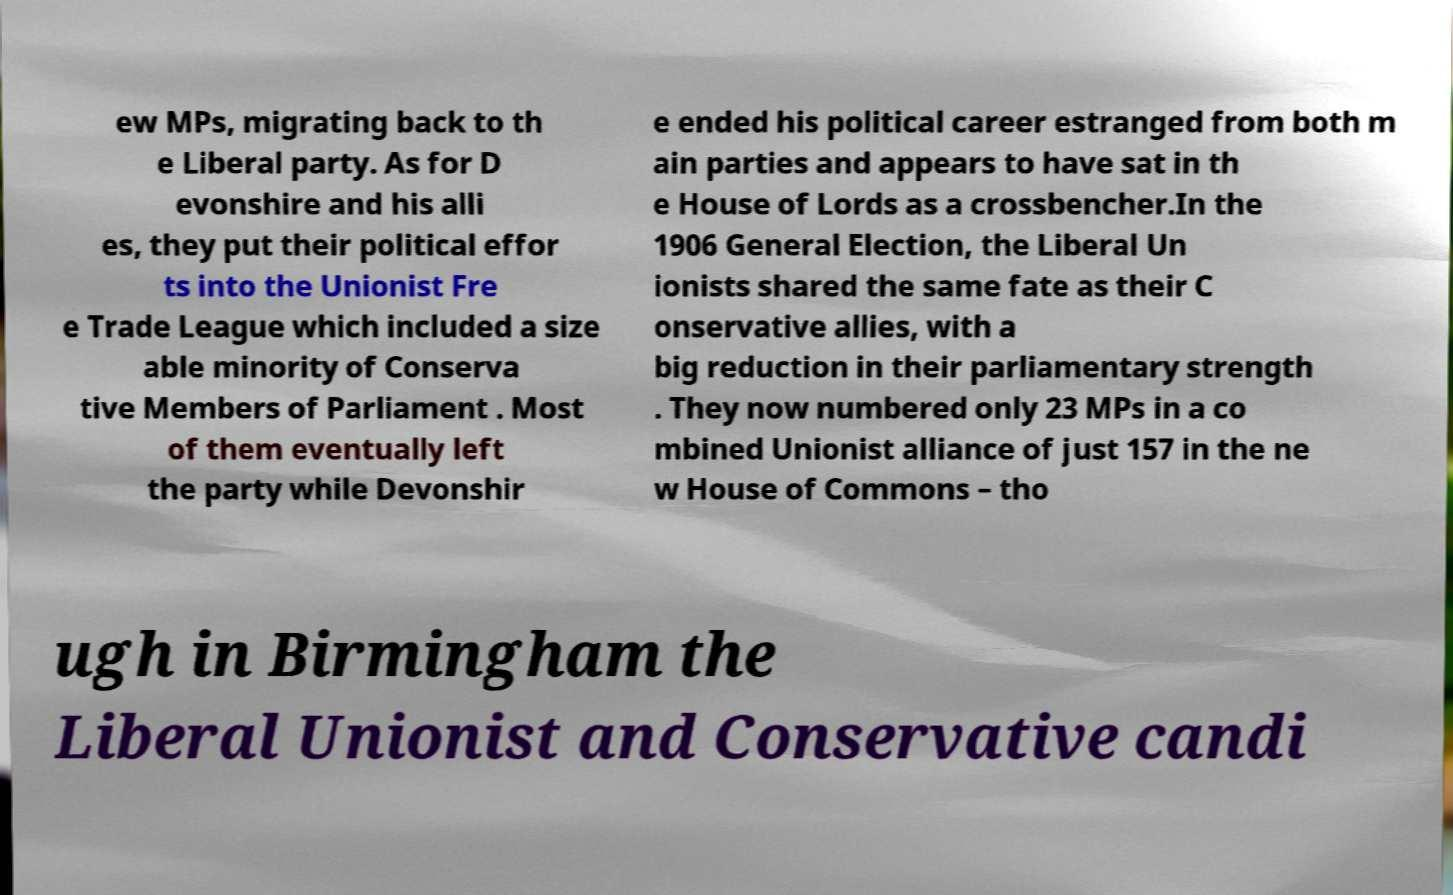Could you extract and type out the text from this image? ew MPs, migrating back to th e Liberal party. As for D evonshire and his alli es, they put their political effor ts into the Unionist Fre e Trade League which included a size able minority of Conserva tive Members of Parliament . Most of them eventually left the party while Devonshir e ended his political career estranged from both m ain parties and appears to have sat in th e House of Lords as a crossbencher.In the 1906 General Election, the Liberal Un ionists shared the same fate as their C onservative allies, with a big reduction in their parliamentary strength . They now numbered only 23 MPs in a co mbined Unionist alliance of just 157 in the ne w House of Commons – tho ugh in Birmingham the Liberal Unionist and Conservative candi 